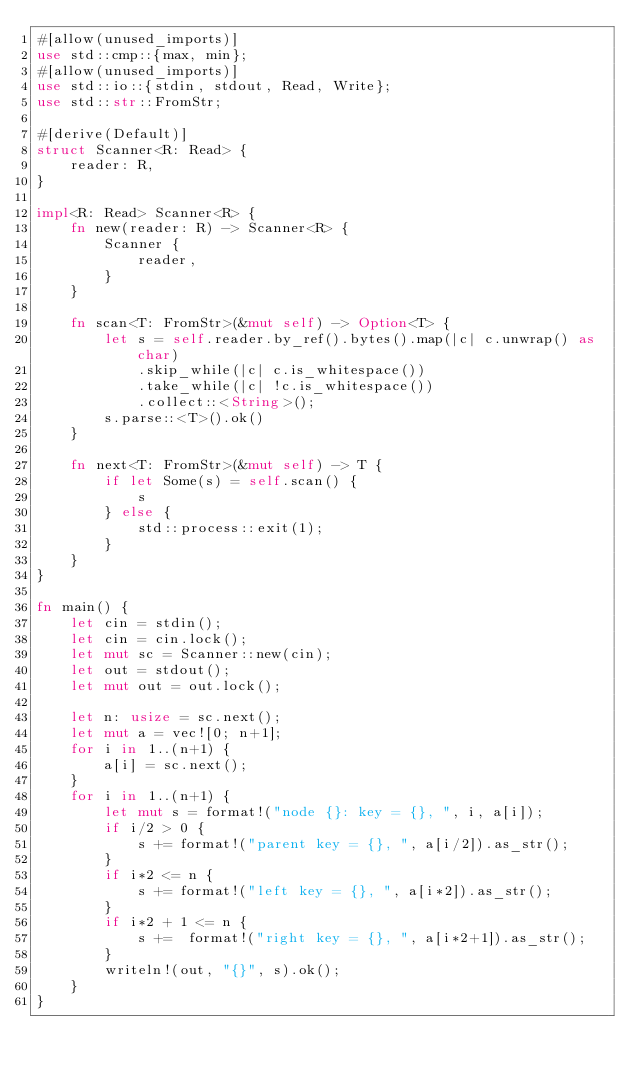Convert code to text. <code><loc_0><loc_0><loc_500><loc_500><_Rust_>#[allow(unused_imports)]
use std::cmp::{max, min};
#[allow(unused_imports)]
use std::io::{stdin, stdout, Read, Write};
use std::str::FromStr;

#[derive(Default)]
struct Scanner<R: Read> {
    reader: R,
}

impl<R: Read> Scanner<R> {
    fn new(reader: R) -> Scanner<R> {
        Scanner {
            reader,
        }
    }

    fn scan<T: FromStr>(&mut self) -> Option<T> {
        let s = self.reader.by_ref().bytes().map(|c| c.unwrap() as char)
            .skip_while(|c| c.is_whitespace())
            .take_while(|c| !c.is_whitespace())
            .collect::<String>();
        s.parse::<T>().ok()
    }

    fn next<T: FromStr>(&mut self) -> T {
        if let Some(s) = self.scan() {
            s
        } else {
            std::process::exit(1);
        }
    }
}

fn main() {
    let cin = stdin();
    let cin = cin.lock();
    let mut sc = Scanner::new(cin);
    let out = stdout();
    let mut out = out.lock();

    let n: usize = sc.next();
    let mut a = vec![0; n+1];
    for i in 1..(n+1) {
        a[i] = sc.next();
    }
    for i in 1..(n+1) {
        let mut s = format!("node {}: key = {}, ", i, a[i]);
        if i/2 > 0 {
            s += format!("parent key = {}, ", a[i/2]).as_str();
        }
        if i*2 <= n {
            s += format!("left key = {}, ", a[i*2]).as_str();
        }
        if i*2 + 1 <= n {
            s +=  format!("right key = {}, ", a[i*2+1]).as_str();
        }
        writeln!(out, "{}", s).ok();
    }
}
</code> 